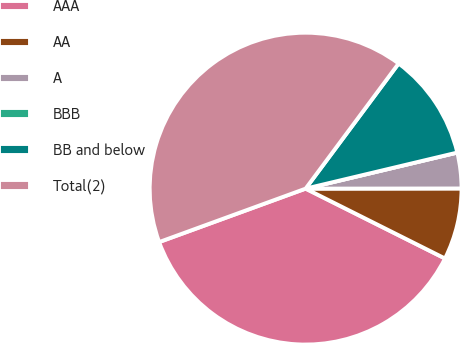<chart> <loc_0><loc_0><loc_500><loc_500><pie_chart><fcel>AAA<fcel>AA<fcel>A<fcel>BBB<fcel>BB and below<fcel>Total(2)<nl><fcel>37.04%<fcel>7.41%<fcel>3.7%<fcel>0.0%<fcel>11.11%<fcel>40.74%<nl></chart> 